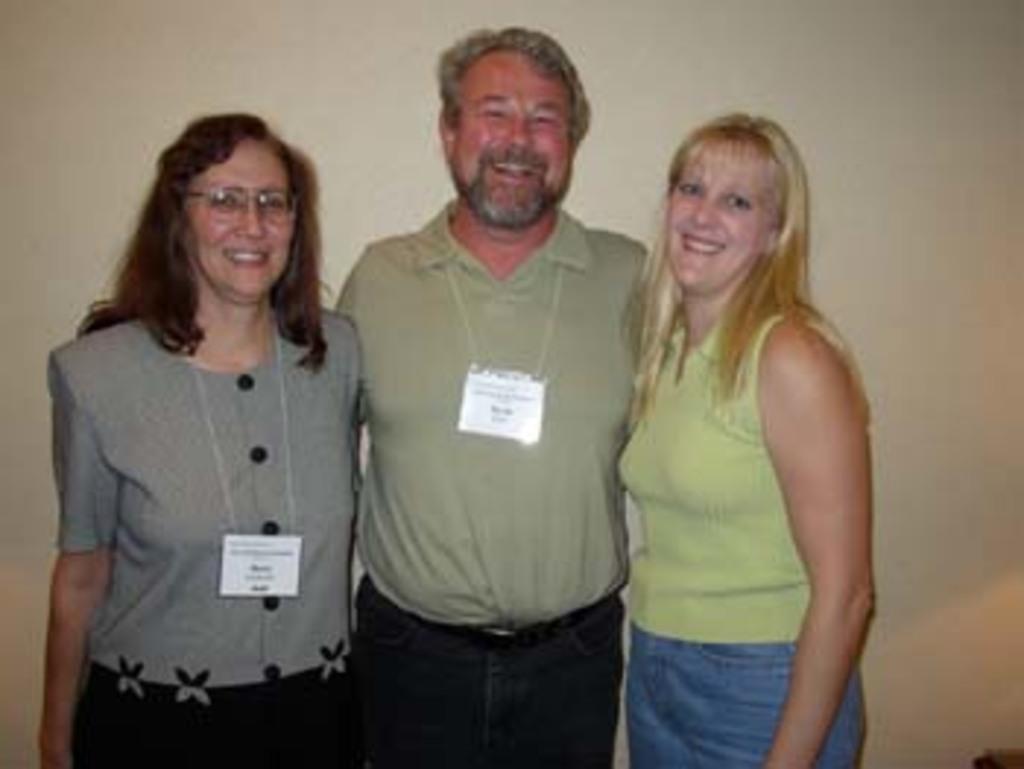Could you give a brief overview of what you see in this image? These three people are standing and smiling. These two people wore id cards. 